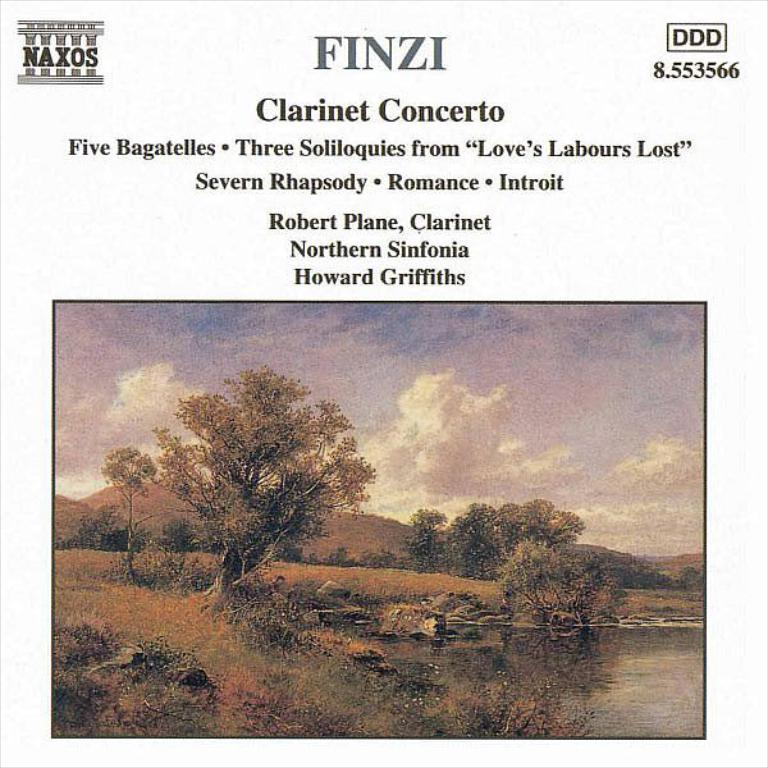What type of natural scenery is depicted in the picture? The picture contains images of trees, a river, mountains, and the sky. Can you describe the different elements of the natural scenery? There are trees, a river, mountains, and the sky depicted in the image. What is the text above the image? Unfortunately, we cannot see the text in the image, as it is not mentioned in the provided facts. What type of patch is being advertised in the image? There is no patch being advertised in the image; the image contains natural scenery and text, but no mention of a patch or advertisement. 